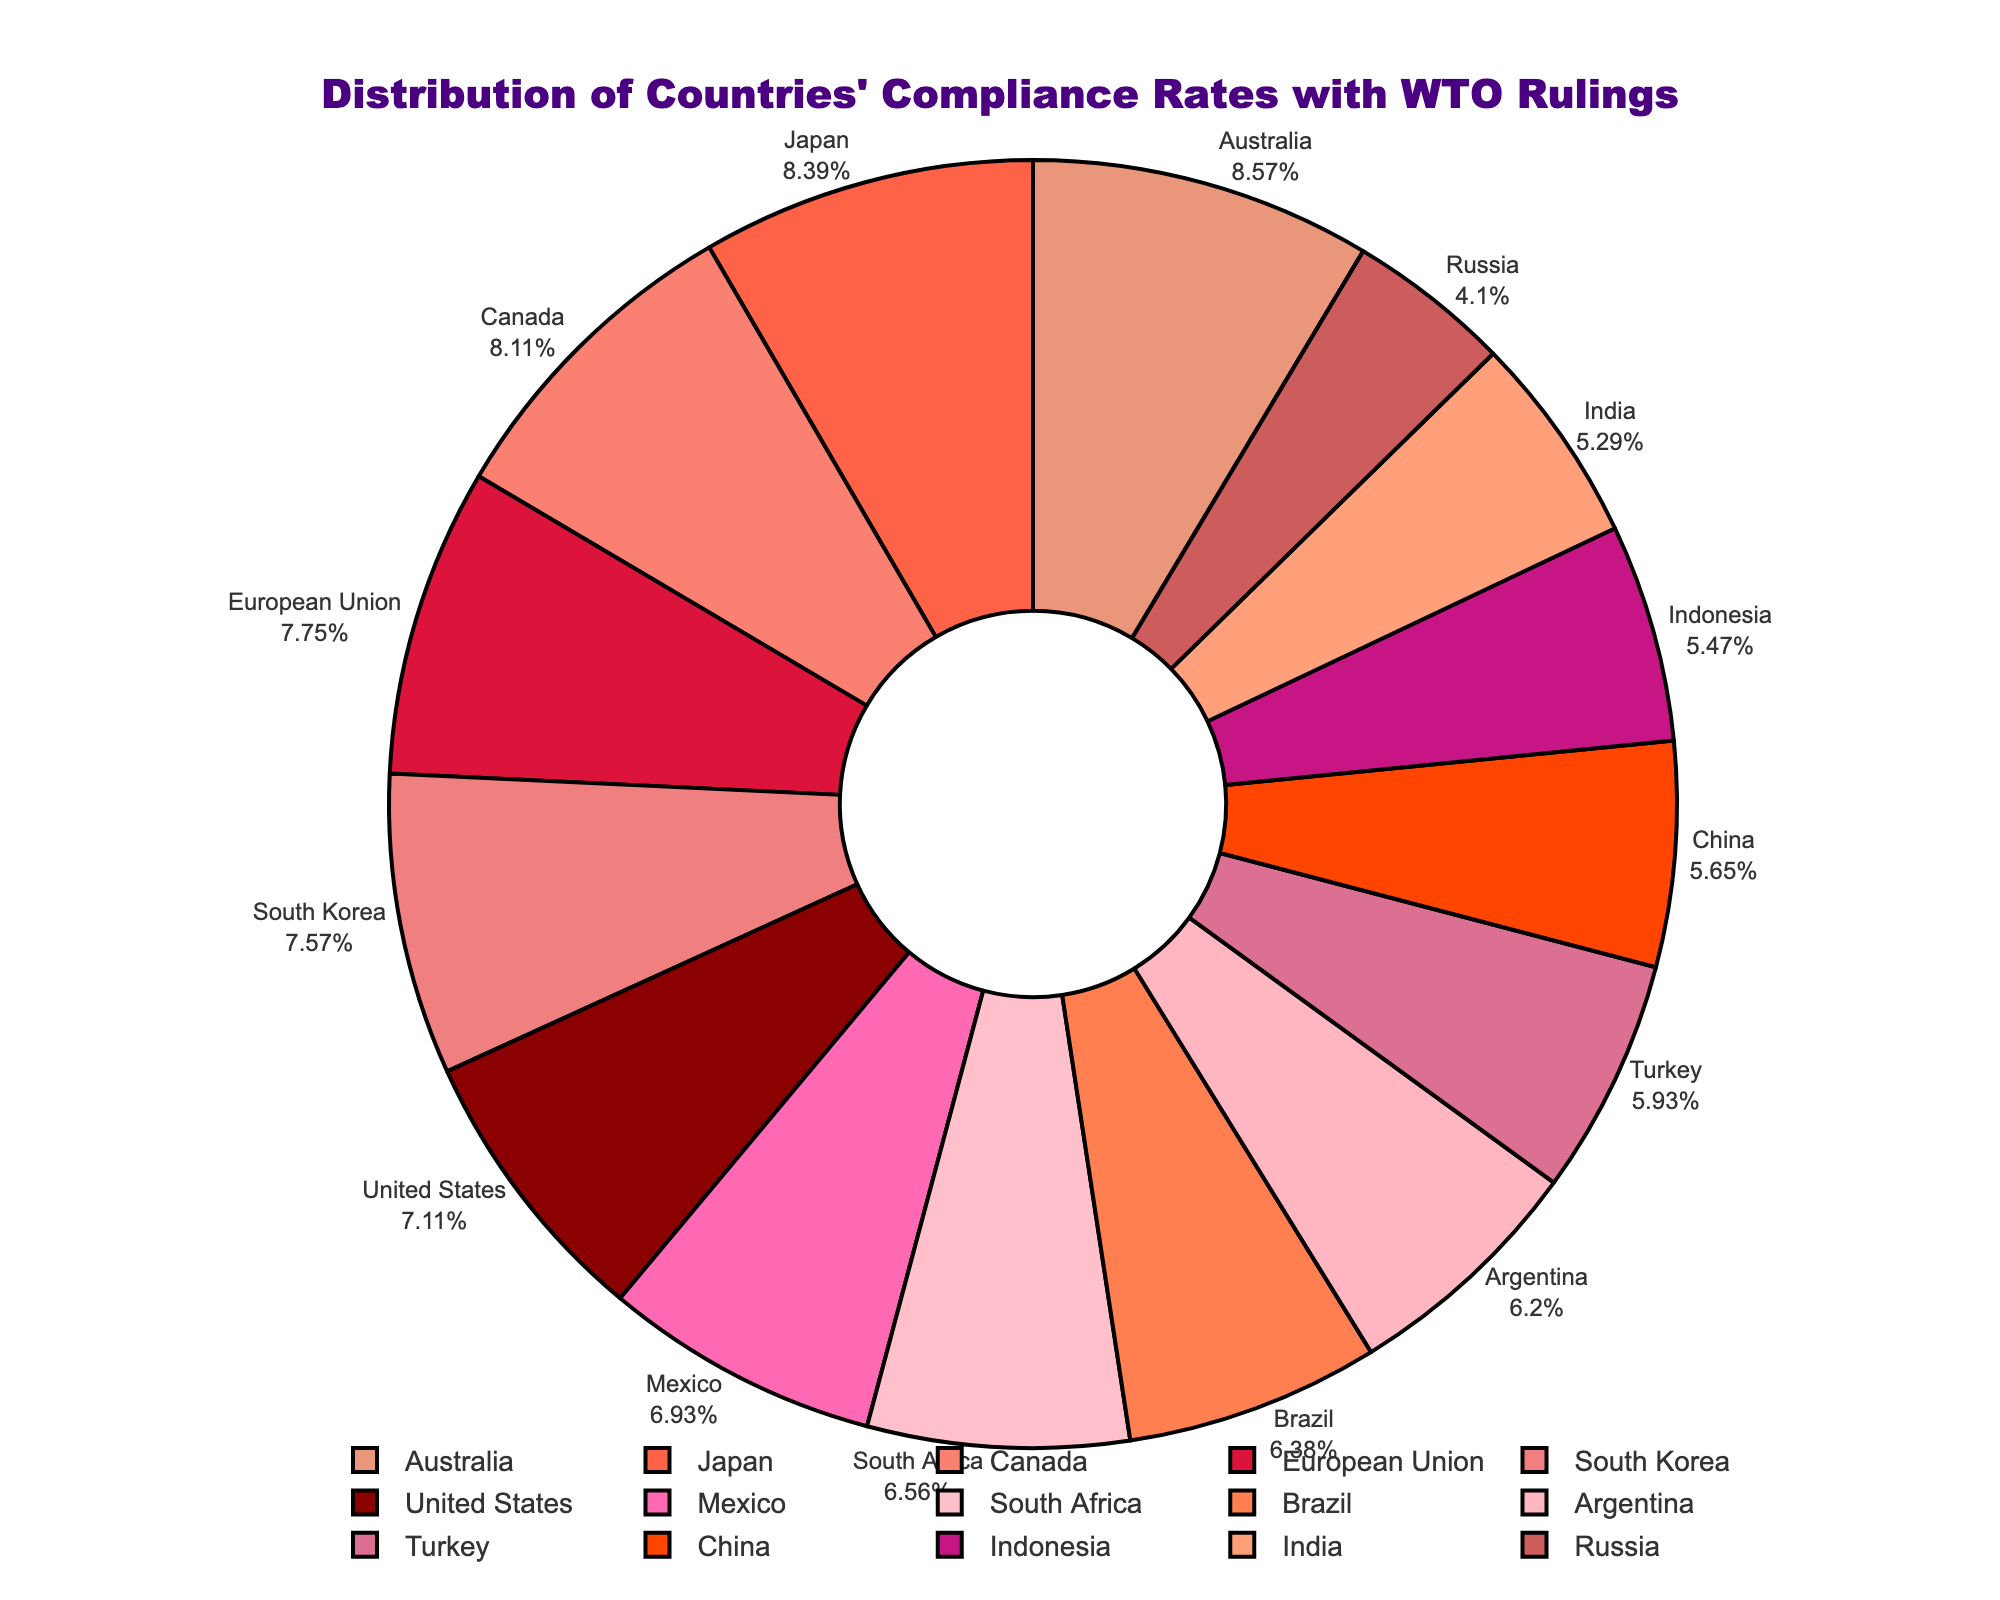what's the country with the highest compliance rate? Look at the pie chart and identify the country segment with the highest value. Australia has the highest compliance rate at 94%.
Answer: Australia Which country has a lower compliance rate: China or India? Compare the compliance rates displayed on the pie chart. China's compliance rate is 62% and India's compliance rate is 58%. India has a lower compliance rate.
Answer: India What is the total compliance rate of Japan and Canada combined? Add the compliance rates of Japan and Canada. Japan's rate is 92% and Canada's rate is 89%. 92 + 89 = 181
Answer: 181 How many countries have a compliance rate below 70%? Count the countries with compliance rates below 70%. China (62%), India (58%), Russia (45%), Argentina (68%), Turkey (65%), Indonesia (60%) which totals to 6 countries.
Answer: 6 What color represents South Korea in the pie chart? Locate the segment for South Korea and note its color. South Korea's segment is in red.
Answer: red 